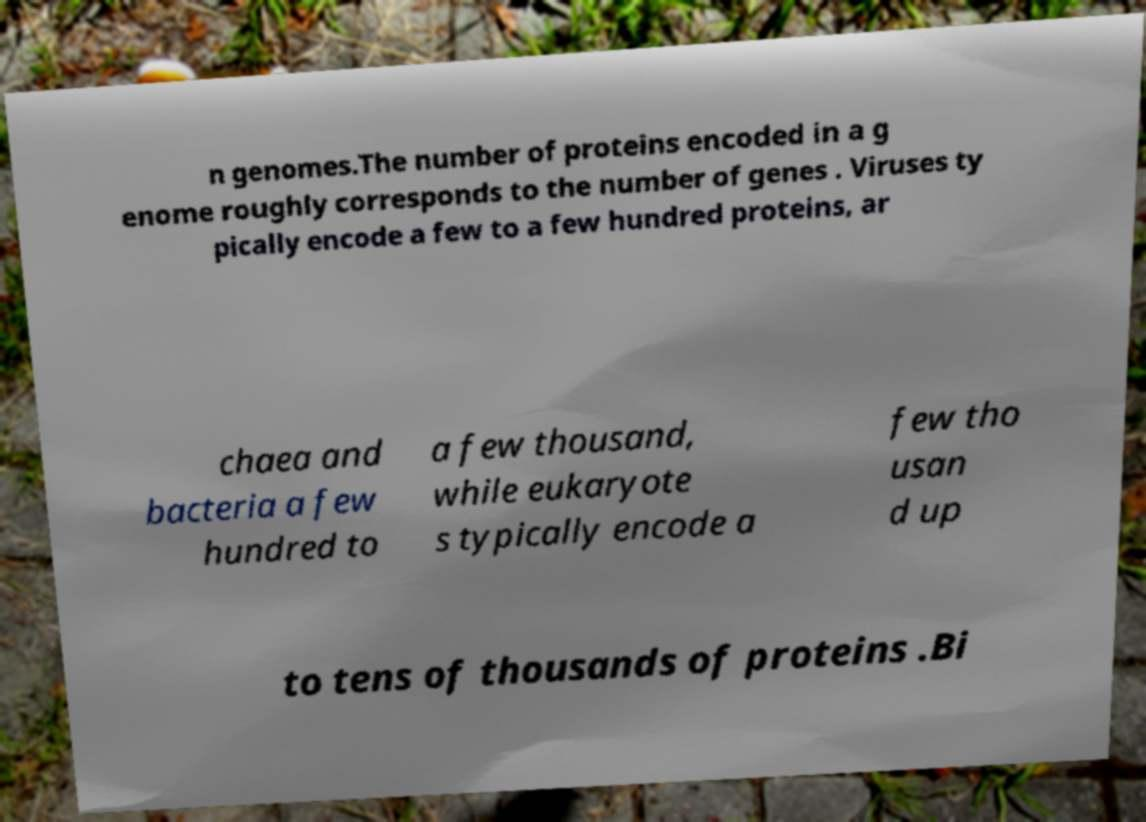Can you accurately transcribe the text from the provided image for me? n genomes.The number of proteins encoded in a g enome roughly corresponds to the number of genes . Viruses ty pically encode a few to a few hundred proteins, ar chaea and bacteria a few hundred to a few thousand, while eukaryote s typically encode a few tho usan d up to tens of thousands of proteins .Bi 